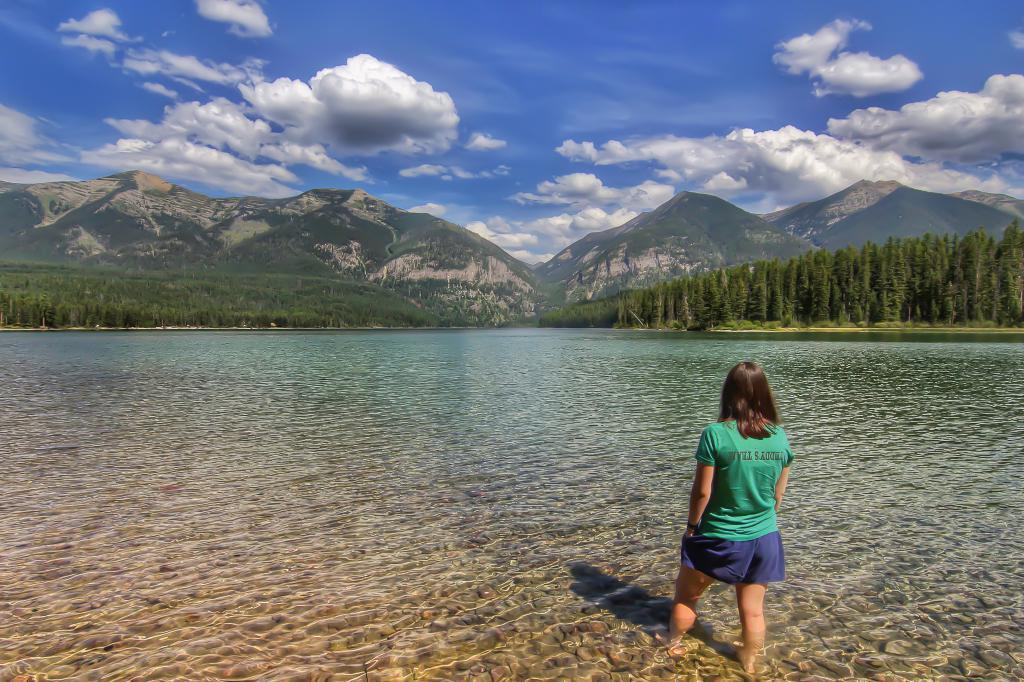What is the lady in the image doing? The lady is standing in the water. What can be seen in the background of the image? There are hills, trees, and the sky visible in the background of the image. What is present at the bottom of the image? There is water at the bottom of the image. What type of art is hanging on the gate in the image? There is no gate present in the image, so it is not possible to answer that question. 